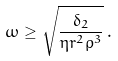Convert formula to latex. <formula><loc_0><loc_0><loc_500><loc_500>\omega \geq \sqrt { \frac { \delta _ { 2 } } { \eta r ^ { 2 } \rho ^ { 3 } } } \, .</formula> 